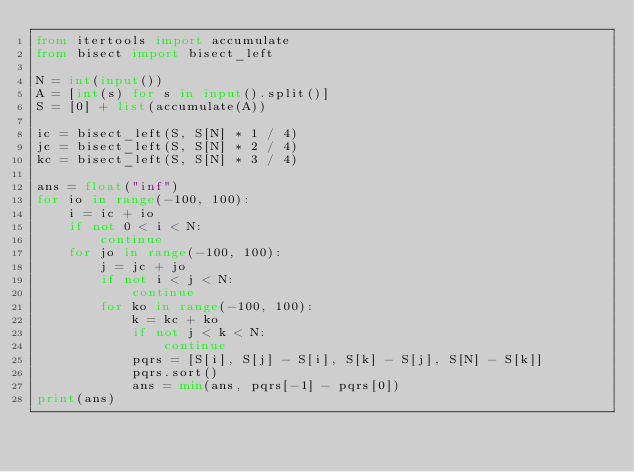<code> <loc_0><loc_0><loc_500><loc_500><_Python_>from itertools import accumulate
from bisect import bisect_left

N = int(input())
A = [int(s) for s in input().split()]
S = [0] + list(accumulate(A))

ic = bisect_left(S, S[N] * 1 / 4)
jc = bisect_left(S, S[N] * 2 / 4)
kc = bisect_left(S, S[N] * 3 / 4)

ans = float("inf")
for io in range(-100, 100):
    i = ic + io
    if not 0 < i < N:
        continue
    for jo in range(-100, 100):
        j = jc + jo
        if not i < j < N:
            continue
        for ko in range(-100, 100):
            k = kc + ko
            if not j < k < N:
                continue
            pqrs = [S[i], S[j] - S[i], S[k] - S[j], S[N] - S[k]]
            pqrs.sort()
            ans = min(ans, pqrs[-1] - pqrs[0])
print(ans)
</code> 